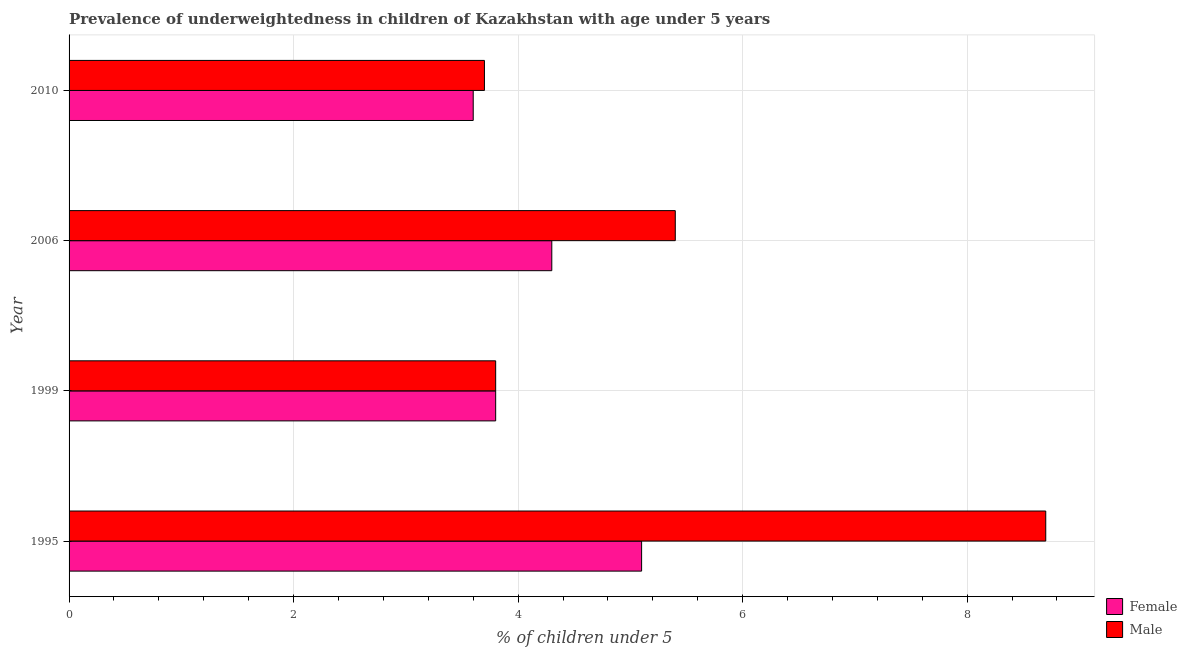How many different coloured bars are there?
Make the answer very short. 2. How many groups of bars are there?
Your answer should be compact. 4. Are the number of bars on each tick of the Y-axis equal?
Provide a succinct answer. Yes. What is the label of the 1st group of bars from the top?
Your answer should be very brief. 2010. In how many cases, is the number of bars for a given year not equal to the number of legend labels?
Provide a succinct answer. 0. What is the percentage of underweighted female children in 1995?
Provide a short and direct response. 5.1. Across all years, what is the maximum percentage of underweighted male children?
Provide a succinct answer. 8.7. Across all years, what is the minimum percentage of underweighted male children?
Give a very brief answer. 3.7. In which year was the percentage of underweighted female children maximum?
Your response must be concise. 1995. What is the total percentage of underweighted female children in the graph?
Provide a succinct answer. 16.8. What is the difference between the percentage of underweighted female children in 1995 and the percentage of underweighted male children in 2006?
Offer a terse response. -0.3. What is the average percentage of underweighted female children per year?
Give a very brief answer. 4.2. In the year 1995, what is the difference between the percentage of underweighted female children and percentage of underweighted male children?
Give a very brief answer. -3.6. What is the ratio of the percentage of underweighted male children in 2006 to that in 2010?
Provide a succinct answer. 1.46. Is the percentage of underweighted female children in 1999 less than that in 2006?
Your response must be concise. Yes. What is the difference between the highest and the lowest percentage of underweighted female children?
Make the answer very short. 1.5. In how many years, is the percentage of underweighted female children greater than the average percentage of underweighted female children taken over all years?
Your answer should be compact. 2. Is the sum of the percentage of underweighted male children in 1995 and 1999 greater than the maximum percentage of underweighted female children across all years?
Ensure brevity in your answer.  Yes. Are all the bars in the graph horizontal?
Make the answer very short. Yes. What is the difference between two consecutive major ticks on the X-axis?
Offer a very short reply. 2. Are the values on the major ticks of X-axis written in scientific E-notation?
Provide a succinct answer. No. Does the graph contain grids?
Offer a terse response. Yes. Where does the legend appear in the graph?
Ensure brevity in your answer.  Bottom right. How many legend labels are there?
Provide a short and direct response. 2. What is the title of the graph?
Provide a short and direct response. Prevalence of underweightedness in children of Kazakhstan with age under 5 years. Does "Age 15+" appear as one of the legend labels in the graph?
Give a very brief answer. No. What is the label or title of the X-axis?
Provide a short and direct response.  % of children under 5. What is the label or title of the Y-axis?
Give a very brief answer. Year. What is the  % of children under 5 in Female in 1995?
Keep it short and to the point. 5.1. What is the  % of children under 5 in Male in 1995?
Provide a short and direct response. 8.7. What is the  % of children under 5 in Female in 1999?
Ensure brevity in your answer.  3.8. What is the  % of children under 5 in Male in 1999?
Your answer should be very brief. 3.8. What is the  % of children under 5 in Female in 2006?
Provide a short and direct response. 4.3. What is the  % of children under 5 of Male in 2006?
Ensure brevity in your answer.  5.4. What is the  % of children under 5 in Female in 2010?
Your response must be concise. 3.6. What is the  % of children under 5 in Male in 2010?
Offer a very short reply. 3.7. Across all years, what is the maximum  % of children under 5 of Female?
Your answer should be very brief. 5.1. Across all years, what is the maximum  % of children under 5 of Male?
Offer a terse response. 8.7. Across all years, what is the minimum  % of children under 5 in Female?
Your answer should be compact. 3.6. Across all years, what is the minimum  % of children under 5 of Male?
Offer a terse response. 3.7. What is the total  % of children under 5 of Male in the graph?
Offer a terse response. 21.6. What is the difference between the  % of children under 5 of Male in 1995 and that in 2006?
Your response must be concise. 3.3. What is the difference between the  % of children under 5 of Female in 1995 and that in 2010?
Give a very brief answer. 1.5. What is the difference between the  % of children under 5 of Male in 1995 and that in 2010?
Provide a succinct answer. 5. What is the difference between the  % of children under 5 in Female in 1999 and that in 2006?
Offer a very short reply. -0.5. What is the difference between the  % of children under 5 in Female in 1999 and that in 2010?
Keep it short and to the point. 0.2. What is the difference between the  % of children under 5 in Male in 1999 and that in 2010?
Provide a succinct answer. 0.1. What is the difference between the  % of children under 5 in Male in 2006 and that in 2010?
Keep it short and to the point. 1.7. What is the difference between the  % of children under 5 in Female in 1995 and the  % of children under 5 in Male in 2006?
Your response must be concise. -0.3. What is the difference between the  % of children under 5 of Female in 1999 and the  % of children under 5 of Male in 2006?
Provide a succinct answer. -1.6. In the year 2010, what is the difference between the  % of children under 5 in Female and  % of children under 5 in Male?
Provide a succinct answer. -0.1. What is the ratio of the  % of children under 5 of Female in 1995 to that in 1999?
Offer a terse response. 1.34. What is the ratio of the  % of children under 5 in Male in 1995 to that in 1999?
Offer a very short reply. 2.29. What is the ratio of the  % of children under 5 in Female in 1995 to that in 2006?
Make the answer very short. 1.19. What is the ratio of the  % of children under 5 in Male in 1995 to that in 2006?
Ensure brevity in your answer.  1.61. What is the ratio of the  % of children under 5 in Female in 1995 to that in 2010?
Your answer should be very brief. 1.42. What is the ratio of the  % of children under 5 in Male in 1995 to that in 2010?
Give a very brief answer. 2.35. What is the ratio of the  % of children under 5 in Female in 1999 to that in 2006?
Provide a short and direct response. 0.88. What is the ratio of the  % of children under 5 in Male in 1999 to that in 2006?
Keep it short and to the point. 0.7. What is the ratio of the  % of children under 5 of Female in 1999 to that in 2010?
Provide a short and direct response. 1.06. What is the ratio of the  % of children under 5 of Female in 2006 to that in 2010?
Make the answer very short. 1.19. What is the ratio of the  % of children under 5 of Male in 2006 to that in 2010?
Offer a very short reply. 1.46. 